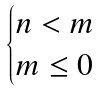<formula> <loc_0><loc_0><loc_500><loc_500>\begin{cases} n < m \\ m \leq 0 \end{cases}</formula> 